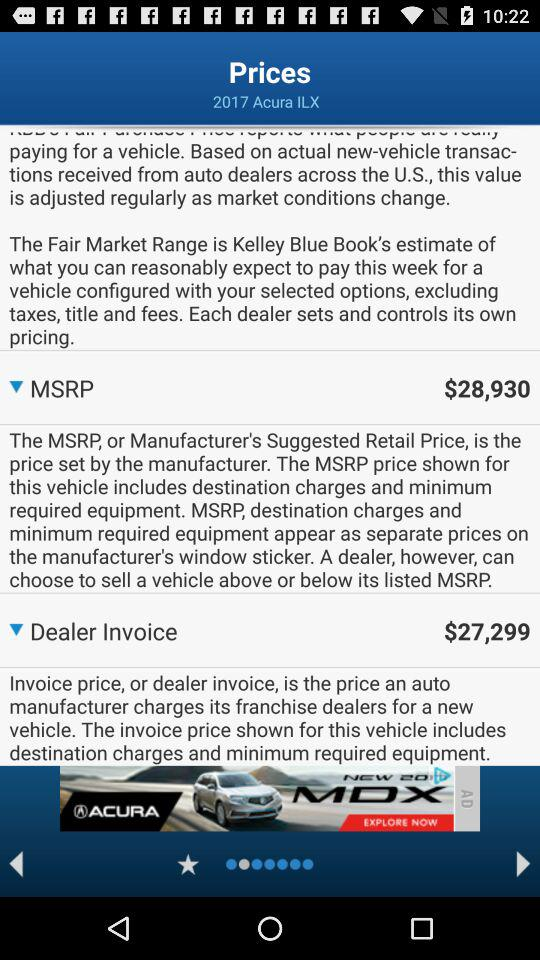How much is the difference between the MSRP and the Dealer Invoice?
Answer the question using a single word or phrase. $1631 